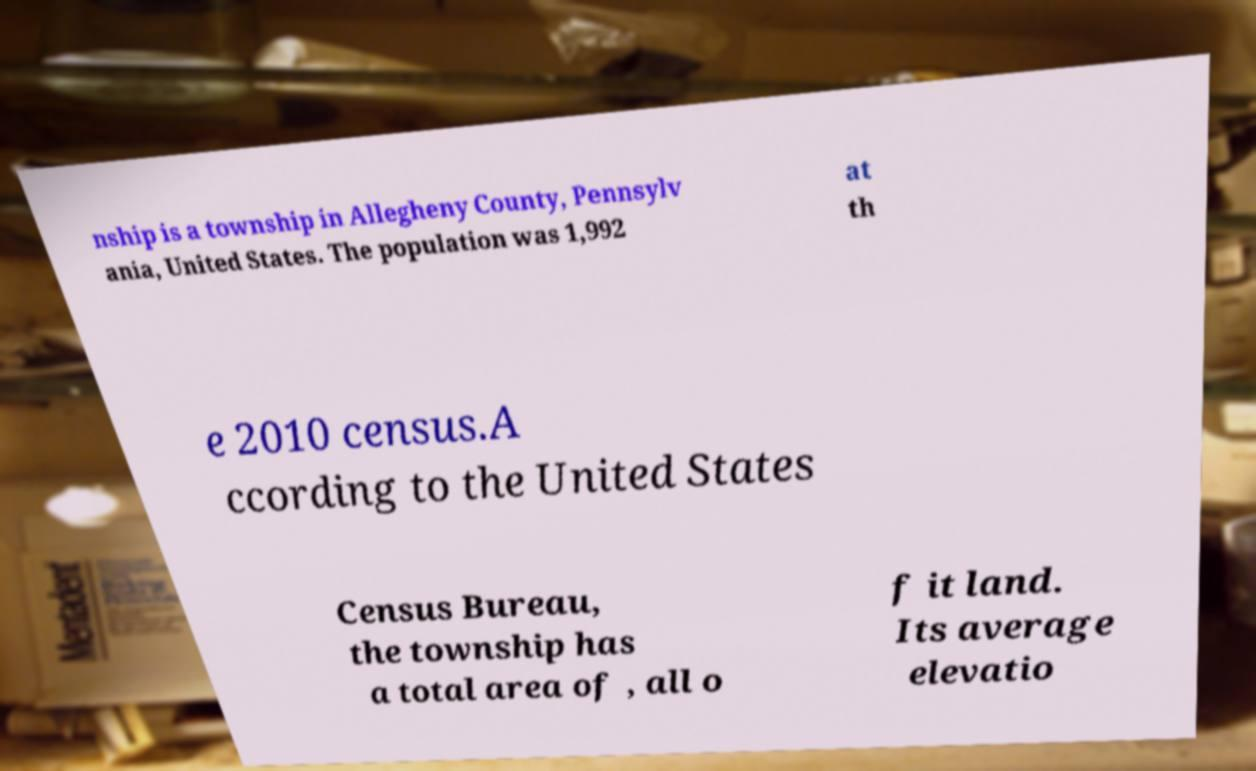I need the written content from this picture converted into text. Can you do that? nship is a township in Allegheny County, Pennsylv ania, United States. The population was 1,992 at th e 2010 census.A ccording to the United States Census Bureau, the township has a total area of , all o f it land. Its average elevatio 